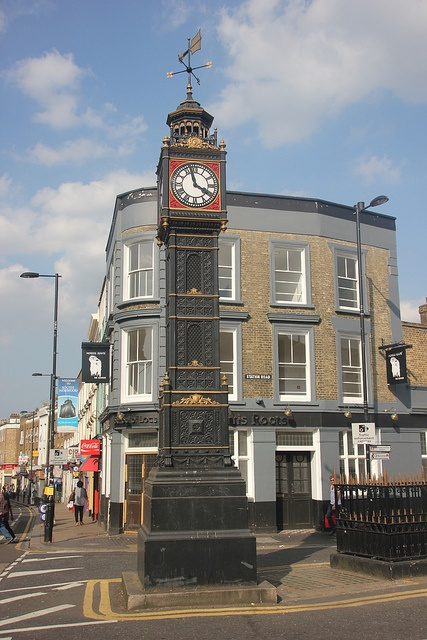Describe the objects in this image and their specific colors. I can see clock in gray, ivory, darkgray, and black tones, people in gray, black, darkgray, and brown tones, people in gray, black, maroon, and darkgray tones, people in gray, black, and maroon tones, and people in gray, black, and darkgray tones in this image. 